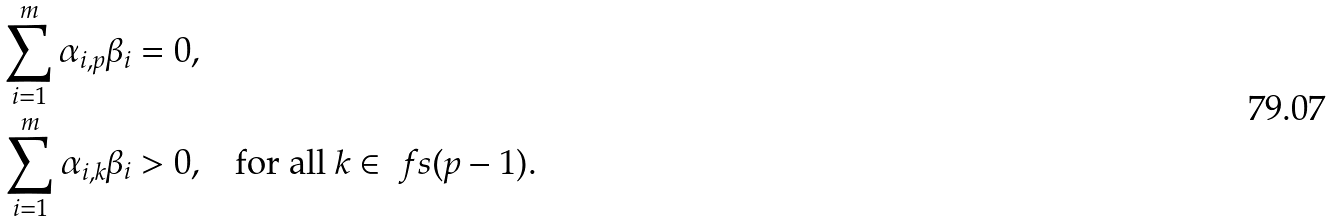Convert formula to latex. <formula><loc_0><loc_0><loc_500><loc_500>\sum _ { i = 1 } ^ { m } \alpha _ { i , p } \beta _ { i } = 0 , & \\ \sum _ { i = 1 } ^ { m } \alpha _ { i , k } \beta _ { i } > 0 , & \quad \text {for all } k \in \ f s ( p - 1 ) .</formula> 